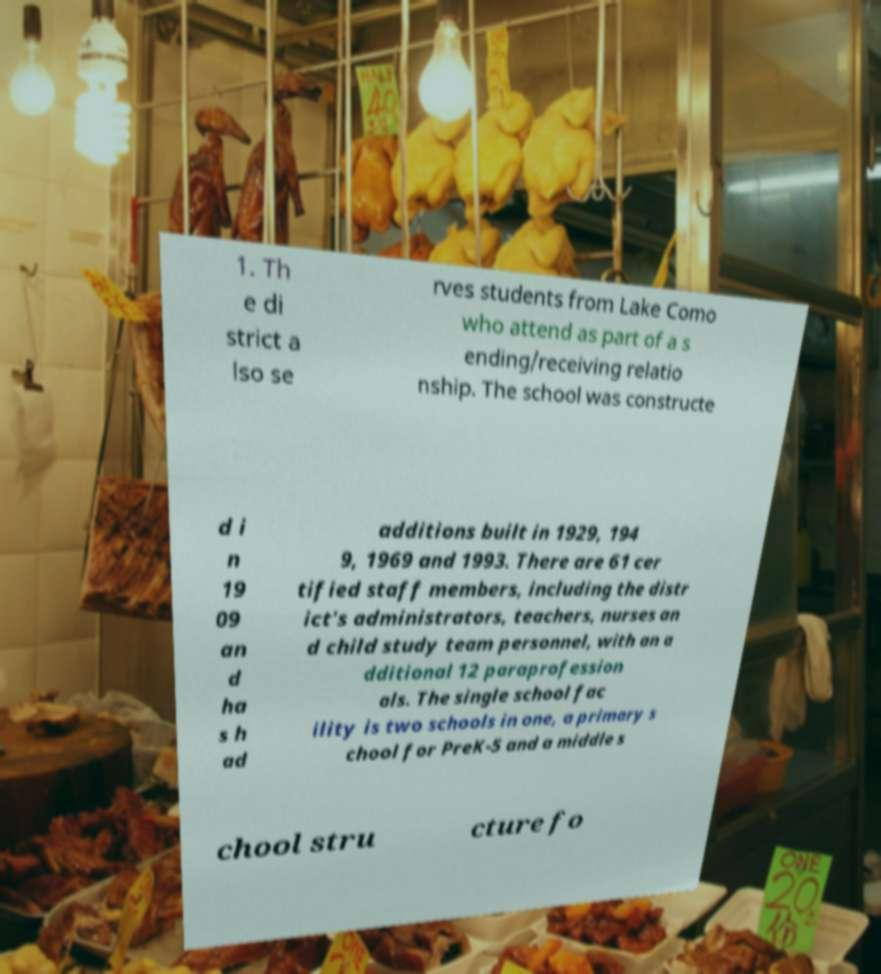Could you assist in decoding the text presented in this image and type it out clearly? 1. Th e di strict a lso se rves students from Lake Como who attend as part of a s ending/receiving relatio nship. The school was constructe d i n 19 09 an d ha s h ad additions built in 1929, 194 9, 1969 and 1993. There are 61 cer tified staff members, including the distr ict's administrators, teachers, nurses an d child study team personnel, with an a dditional 12 paraprofession als. The single school fac ility is two schools in one, a primary s chool for PreK-5 and a middle s chool stru cture fo 